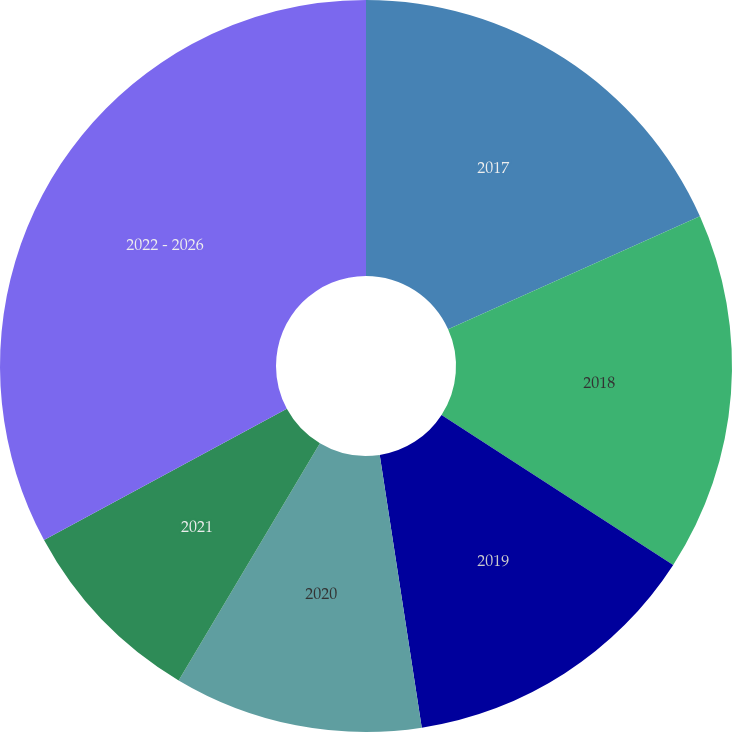Convert chart to OTSL. <chart><loc_0><loc_0><loc_500><loc_500><pie_chart><fcel>2017<fcel>2018<fcel>2019<fcel>2020<fcel>2021<fcel>2022 - 2026<nl><fcel>18.29%<fcel>15.86%<fcel>13.42%<fcel>10.99%<fcel>8.56%<fcel>32.89%<nl></chart> 